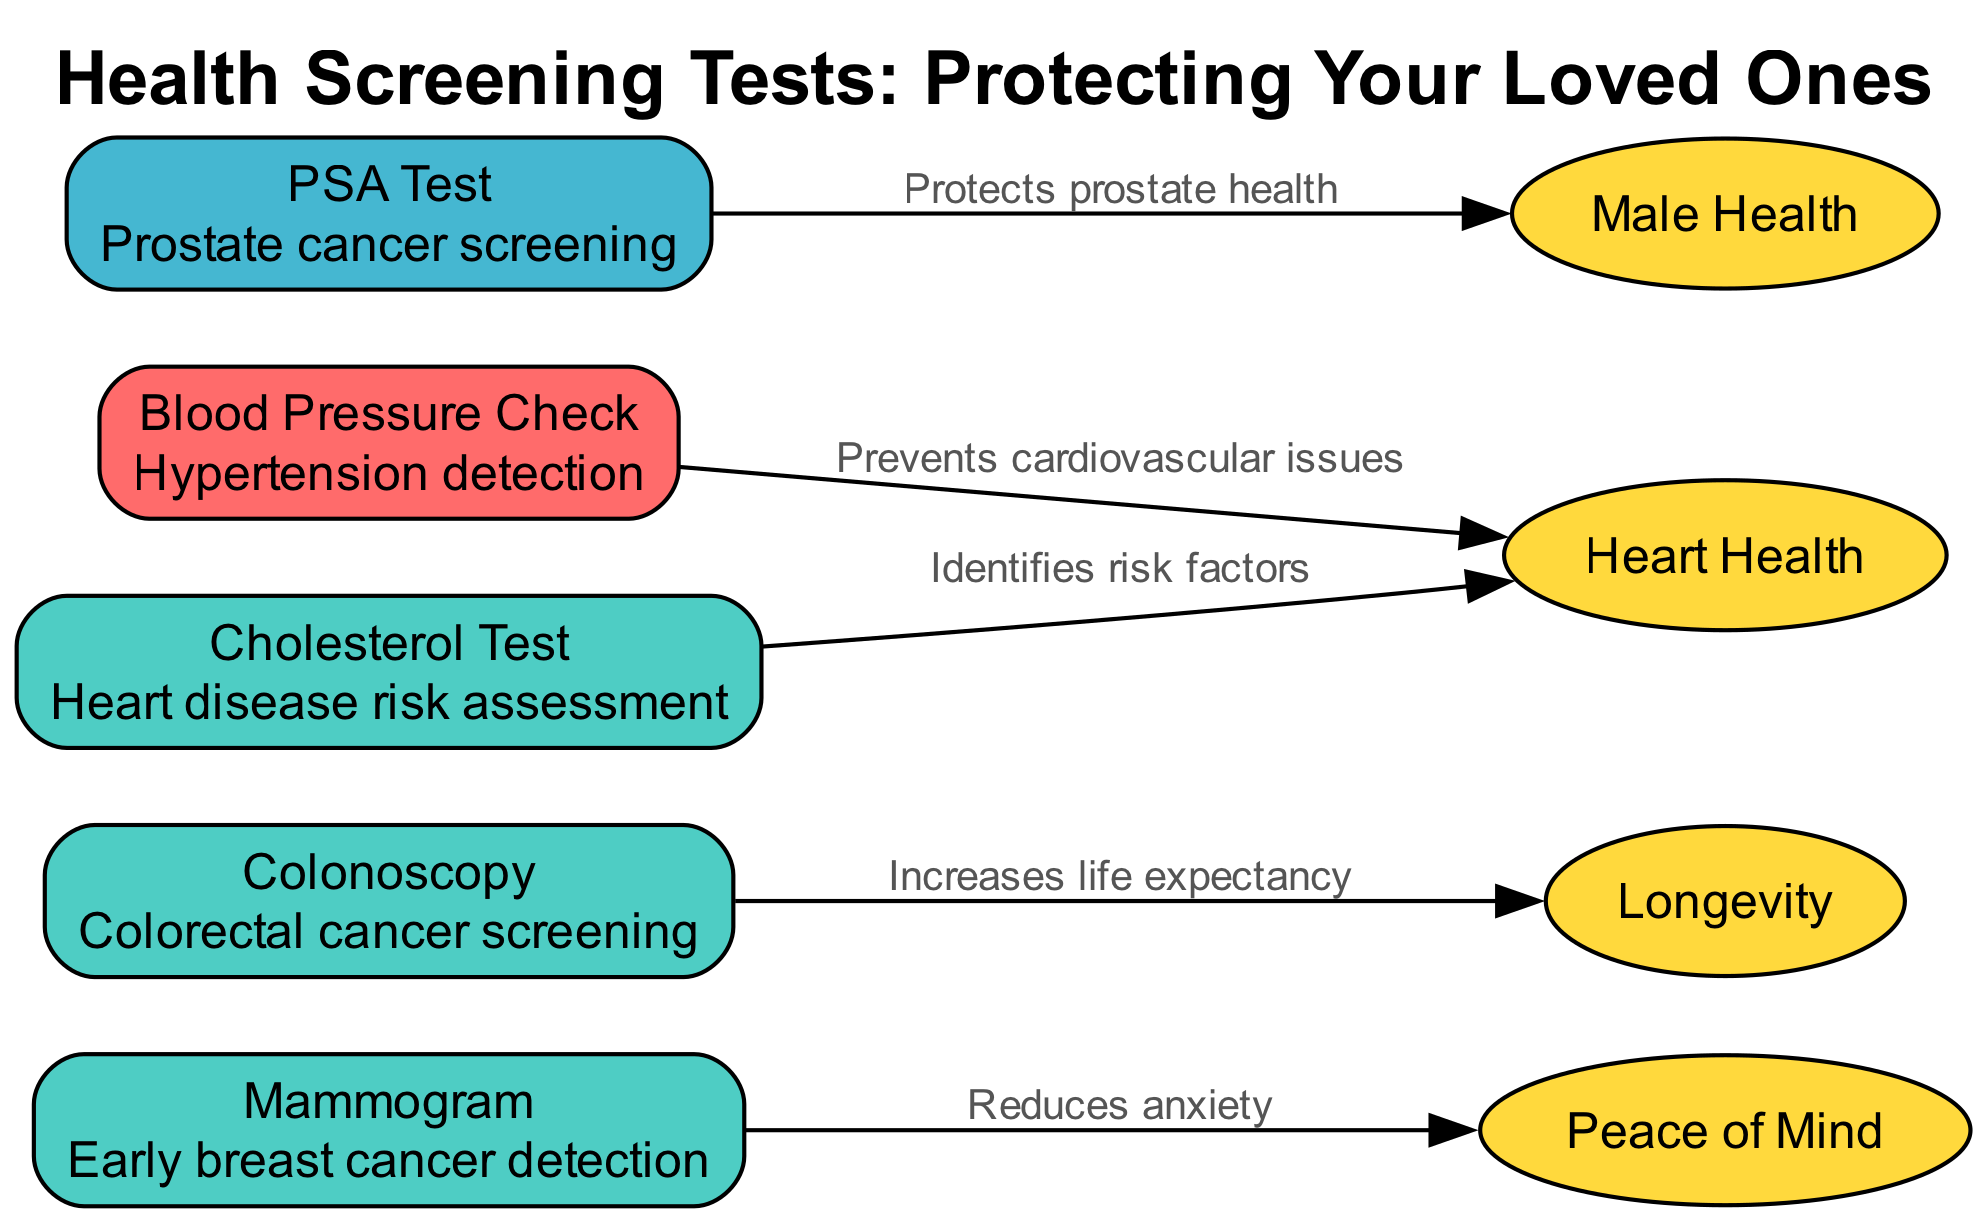What is the most critical health screening test? The diagram shows the "Blood Pressure Check" labeled with the importance "Critical." This indicates that among all the screening tests listed, this one is deemed the most critical for health monitoring.
Answer: Blood Pressure Check How many health screening tests are listed in the diagram? By counting the nodes in the diagram, there are five health screening tests mentioned: Mammogram, Colonoscopy, Blood Pressure Check, Cholesterol Test, and PSA Test.
Answer: 5 Which test is associated with reducing anxiety? The diagram indicates that the "Mammogram" is connected to the outcome "Peace of Mind" with a label stating "Reduces anxiety." Therefore, it is this specific screening test that is associated with lowering anxiety levels.
Answer: Mammogram What outcome is linked to the Colonoscopy? According to the diagram, the "Colonoscopy" is connected to the outcome "Longevity," with the label "Increases life expectancy," indicating its importance in promoting longer life.
Answer: Longevity Which tests are categorized with "High" importance? The nodes for "Mammogram," "Colonoscopy," "Cholesterol Test" are all marked with "High" importance in the diagram. Therefore, these three tests belong to that category.
Answer: Mammogram, Colonoscopy, Cholesterol Test What specific outcome is related to the PSA Test? The diagram shows that the "PSA Test" connects to "Male Health" with the label "Protects prostate health," indicating its specific focus on prostate health for males.
Answer: Male Health Which health screening test helps prevent cardiovascular issues? The diagram connects the "Blood Pressure Check" to the outcome "Heart Health" with the label "Prevents cardiovascular issues," indicating its role in preventing such problems.
Answer: Blood Pressure Check Which node indicates an importance of "Moderate"? Within the diagram, the "PSA Test" is the only node classified with "Moderate" importance, distinguishing it from the other tests which have either "High" or "Critical" importance levels.
Answer: PSA Test 